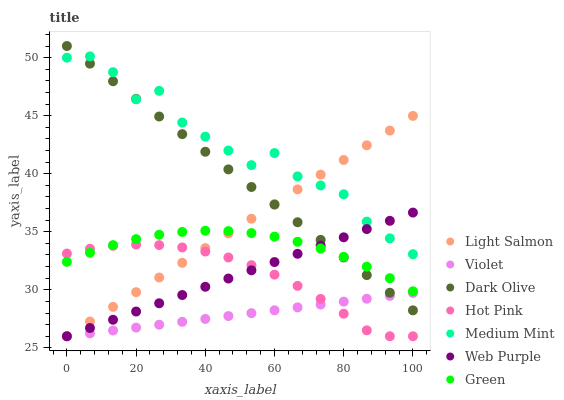Does Violet have the minimum area under the curve?
Answer yes or no. Yes. Does Medium Mint have the maximum area under the curve?
Answer yes or no. Yes. Does Light Salmon have the minimum area under the curve?
Answer yes or no. No. Does Light Salmon have the maximum area under the curve?
Answer yes or no. No. Is Violet the smoothest?
Answer yes or no. Yes. Is Medium Mint the roughest?
Answer yes or no. Yes. Is Light Salmon the smoothest?
Answer yes or no. No. Is Light Salmon the roughest?
Answer yes or no. No. Does Light Salmon have the lowest value?
Answer yes or no. Yes. Does Dark Olive have the lowest value?
Answer yes or no. No. Does Dark Olive have the highest value?
Answer yes or no. Yes. Does Light Salmon have the highest value?
Answer yes or no. No. Is Green less than Medium Mint?
Answer yes or no. Yes. Is Green greater than Violet?
Answer yes or no. Yes. Does Medium Mint intersect Web Purple?
Answer yes or no. Yes. Is Medium Mint less than Web Purple?
Answer yes or no. No. Is Medium Mint greater than Web Purple?
Answer yes or no. No. Does Green intersect Medium Mint?
Answer yes or no. No. 